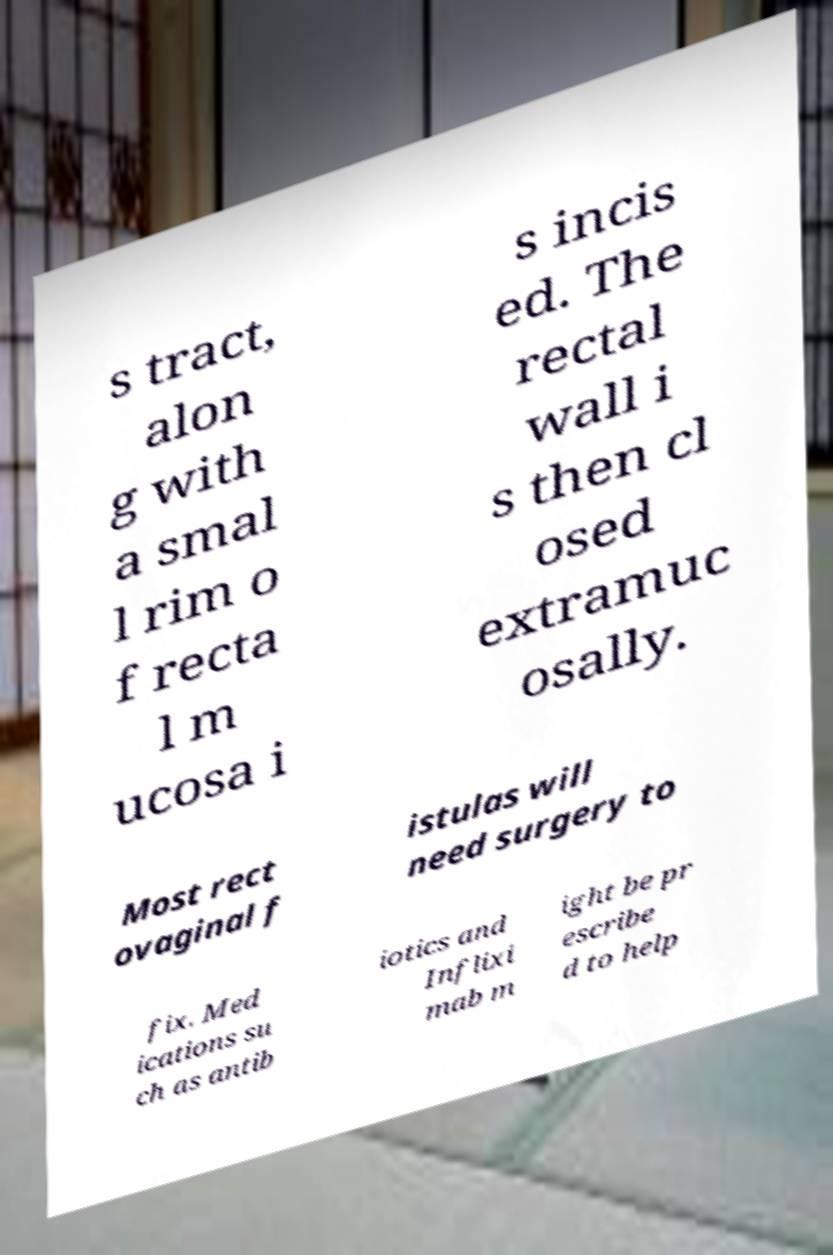Can you accurately transcribe the text from the provided image for me? s tract, alon g with a smal l rim o f recta l m ucosa i s incis ed. The rectal wall i s then cl osed extramuc osally. Most rect ovaginal f istulas will need surgery to fix. Med ications su ch as antib iotics and Inflixi mab m ight be pr escribe d to help 